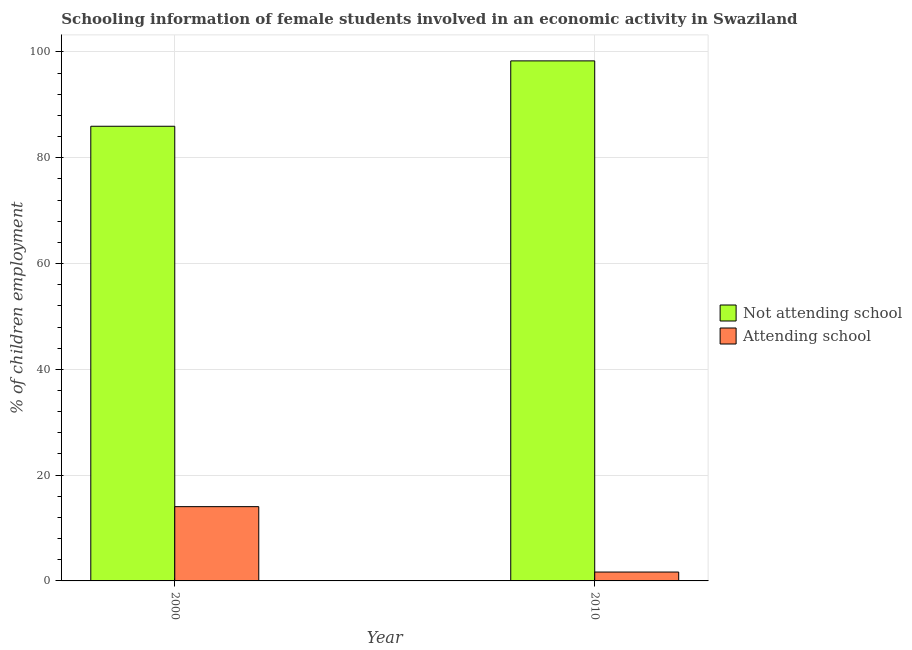How many different coloured bars are there?
Ensure brevity in your answer.  2. How many groups of bars are there?
Offer a very short reply. 2. Are the number of bars per tick equal to the number of legend labels?
Your answer should be compact. Yes. How many bars are there on the 2nd tick from the left?
Provide a short and direct response. 2. How many bars are there on the 2nd tick from the right?
Your answer should be compact. 2. What is the label of the 2nd group of bars from the left?
Offer a terse response. 2010. What is the percentage of employed females who are attending school in 2010?
Your answer should be compact. 1.68. Across all years, what is the maximum percentage of employed females who are attending school?
Provide a short and direct response. 14.04. Across all years, what is the minimum percentage of employed females who are attending school?
Your answer should be very brief. 1.68. What is the total percentage of employed females who are not attending school in the graph?
Give a very brief answer. 184.28. What is the difference between the percentage of employed females who are not attending school in 2000 and that in 2010?
Give a very brief answer. -12.36. What is the difference between the percentage of employed females who are attending school in 2010 and the percentage of employed females who are not attending school in 2000?
Your answer should be compact. -12.36. What is the average percentage of employed females who are not attending school per year?
Provide a succinct answer. 92.14. In the year 2010, what is the difference between the percentage of employed females who are not attending school and percentage of employed females who are attending school?
Your answer should be compact. 0. What is the ratio of the percentage of employed females who are attending school in 2000 to that in 2010?
Your answer should be very brief. 8.36. Is the percentage of employed females who are attending school in 2000 less than that in 2010?
Offer a very short reply. No. What does the 2nd bar from the left in 2010 represents?
Your answer should be very brief. Attending school. What does the 2nd bar from the right in 2010 represents?
Your answer should be very brief. Not attending school. How many bars are there?
Your answer should be compact. 4. Are all the bars in the graph horizontal?
Your answer should be compact. No. What is the difference between two consecutive major ticks on the Y-axis?
Offer a terse response. 20. Are the values on the major ticks of Y-axis written in scientific E-notation?
Keep it short and to the point. No. Does the graph contain any zero values?
Your answer should be very brief. No. What is the title of the graph?
Your answer should be very brief. Schooling information of female students involved in an economic activity in Swaziland. Does "Urban agglomerations" appear as one of the legend labels in the graph?
Provide a succinct answer. No. What is the label or title of the X-axis?
Provide a succinct answer. Year. What is the label or title of the Y-axis?
Make the answer very short. % of children employment. What is the % of children employment in Not attending school in 2000?
Provide a short and direct response. 85.96. What is the % of children employment of Attending school in 2000?
Provide a succinct answer. 14.04. What is the % of children employment of Not attending school in 2010?
Your answer should be compact. 98.32. What is the % of children employment in Attending school in 2010?
Ensure brevity in your answer.  1.68. Across all years, what is the maximum % of children employment in Not attending school?
Your response must be concise. 98.32. Across all years, what is the maximum % of children employment of Attending school?
Ensure brevity in your answer.  14.04. Across all years, what is the minimum % of children employment of Not attending school?
Provide a short and direct response. 85.96. Across all years, what is the minimum % of children employment in Attending school?
Your answer should be very brief. 1.68. What is the total % of children employment in Not attending school in the graph?
Give a very brief answer. 184.28. What is the total % of children employment in Attending school in the graph?
Offer a very short reply. 15.72. What is the difference between the % of children employment of Not attending school in 2000 and that in 2010?
Make the answer very short. -12.36. What is the difference between the % of children employment in Attending school in 2000 and that in 2010?
Your answer should be compact. 12.36. What is the difference between the % of children employment in Not attending school in 2000 and the % of children employment in Attending school in 2010?
Make the answer very short. 84.28. What is the average % of children employment of Not attending school per year?
Ensure brevity in your answer.  92.14. What is the average % of children employment in Attending school per year?
Offer a terse response. 7.86. In the year 2000, what is the difference between the % of children employment in Not attending school and % of children employment in Attending school?
Your response must be concise. 71.92. In the year 2010, what is the difference between the % of children employment in Not attending school and % of children employment in Attending school?
Your answer should be compact. 96.64. What is the ratio of the % of children employment in Not attending school in 2000 to that in 2010?
Your response must be concise. 0.87. What is the ratio of the % of children employment in Attending school in 2000 to that in 2010?
Ensure brevity in your answer.  8.36. What is the difference between the highest and the second highest % of children employment in Not attending school?
Offer a very short reply. 12.36. What is the difference between the highest and the second highest % of children employment in Attending school?
Make the answer very short. 12.36. What is the difference between the highest and the lowest % of children employment of Not attending school?
Give a very brief answer. 12.36. What is the difference between the highest and the lowest % of children employment in Attending school?
Keep it short and to the point. 12.36. 